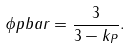Convert formula to latex. <formula><loc_0><loc_0><loc_500><loc_500>\phi p b a r = \frac { 3 } { 3 - k _ { P } } .</formula> 